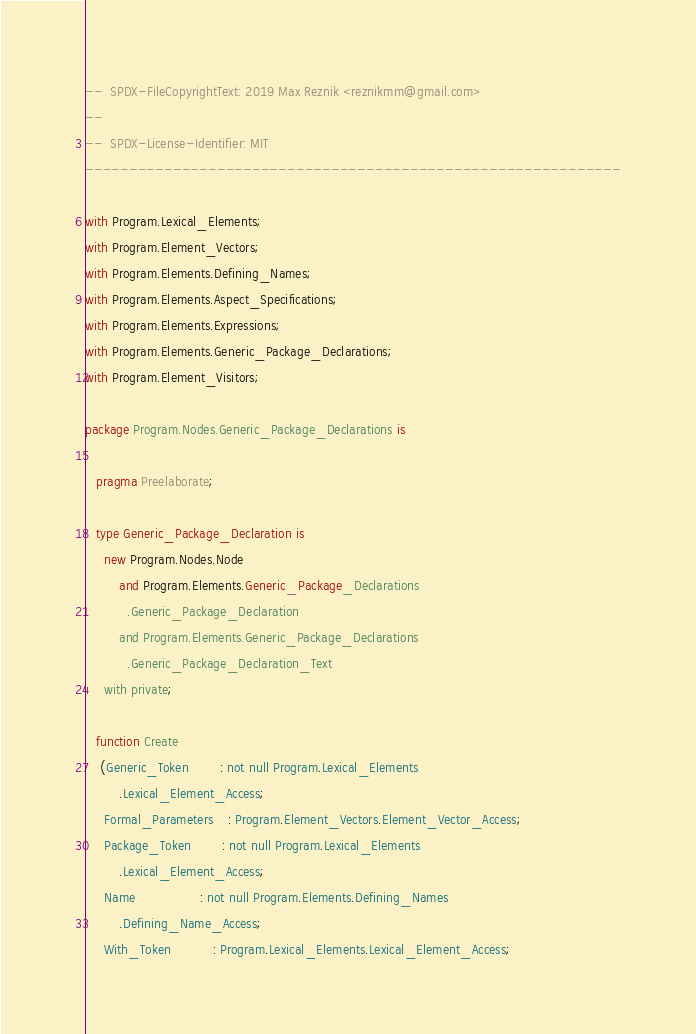<code> <loc_0><loc_0><loc_500><loc_500><_Ada_>--  SPDX-FileCopyrightText: 2019 Max Reznik <reznikmm@gmail.com>
--
--  SPDX-License-Identifier: MIT
-------------------------------------------------------------

with Program.Lexical_Elements;
with Program.Element_Vectors;
with Program.Elements.Defining_Names;
with Program.Elements.Aspect_Specifications;
with Program.Elements.Expressions;
with Program.Elements.Generic_Package_Declarations;
with Program.Element_Visitors;

package Program.Nodes.Generic_Package_Declarations is

   pragma Preelaborate;

   type Generic_Package_Declaration is
     new Program.Nodes.Node
         and Program.Elements.Generic_Package_Declarations
           .Generic_Package_Declaration
         and Program.Elements.Generic_Package_Declarations
           .Generic_Package_Declaration_Text
     with private;

   function Create
    (Generic_Token        : not null Program.Lexical_Elements
         .Lexical_Element_Access;
     Formal_Parameters    : Program.Element_Vectors.Element_Vector_Access;
     Package_Token        : not null Program.Lexical_Elements
         .Lexical_Element_Access;
     Name                 : not null Program.Elements.Defining_Names
         .Defining_Name_Access;
     With_Token           : Program.Lexical_Elements.Lexical_Element_Access;</code> 